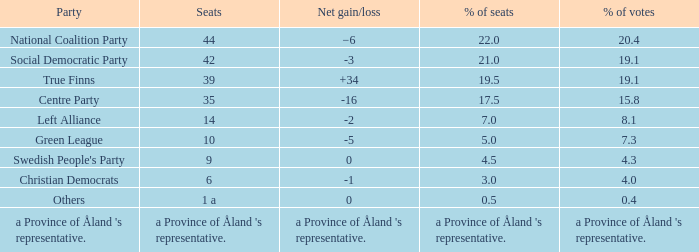For the seats that accounted for 8.1% of the vote, what was the total number held? 14.0. 